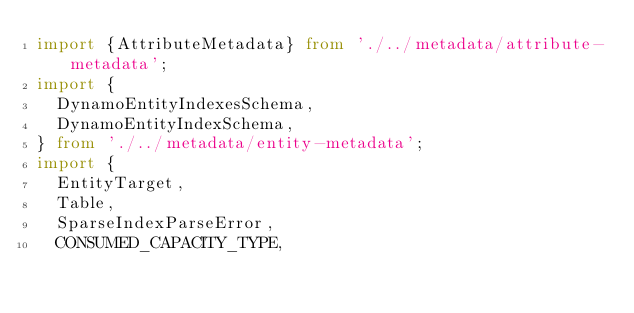<code> <loc_0><loc_0><loc_500><loc_500><_TypeScript_>import {AttributeMetadata} from './../metadata/attribute-metadata';
import {
  DynamoEntityIndexesSchema,
  DynamoEntityIndexSchema,
} from './../metadata/entity-metadata';
import {
  EntityTarget,
  Table,
  SparseIndexParseError,
  CONSUMED_CAPACITY_TYPE,</code> 